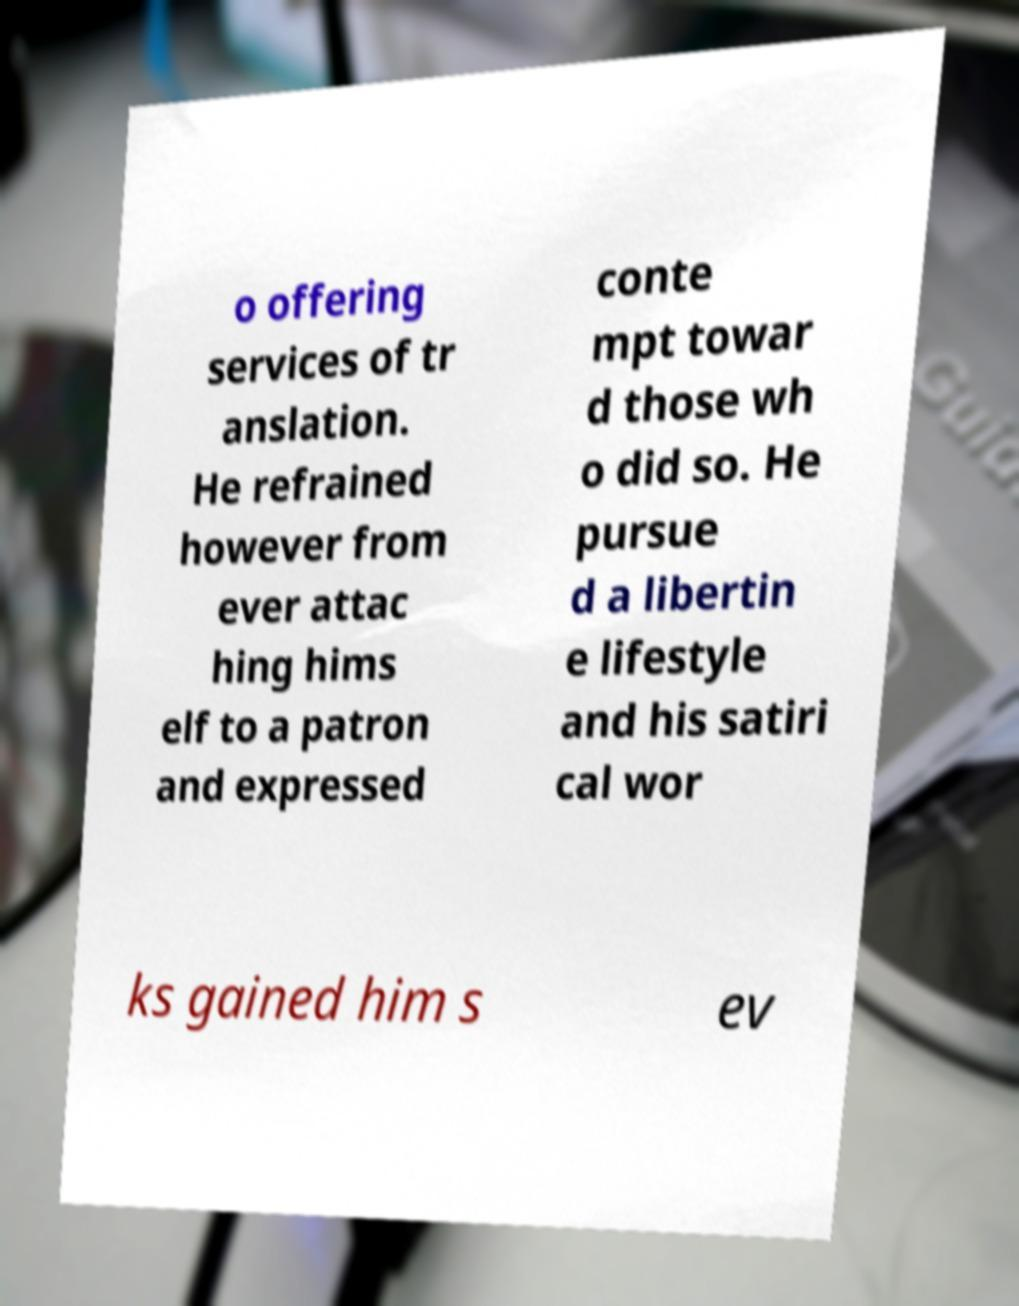Can you accurately transcribe the text from the provided image for me? o offering services of tr anslation. He refrained however from ever attac hing hims elf to a patron and expressed conte mpt towar d those wh o did so. He pursue d a libertin e lifestyle and his satiri cal wor ks gained him s ev 